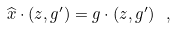Convert formula to latex. <formula><loc_0><loc_0><loc_500><loc_500>\widehat { x } \cdot ( z , g ^ { \prime } ) = g \cdot ( z , g ^ { \prime } ) \ ,</formula> 